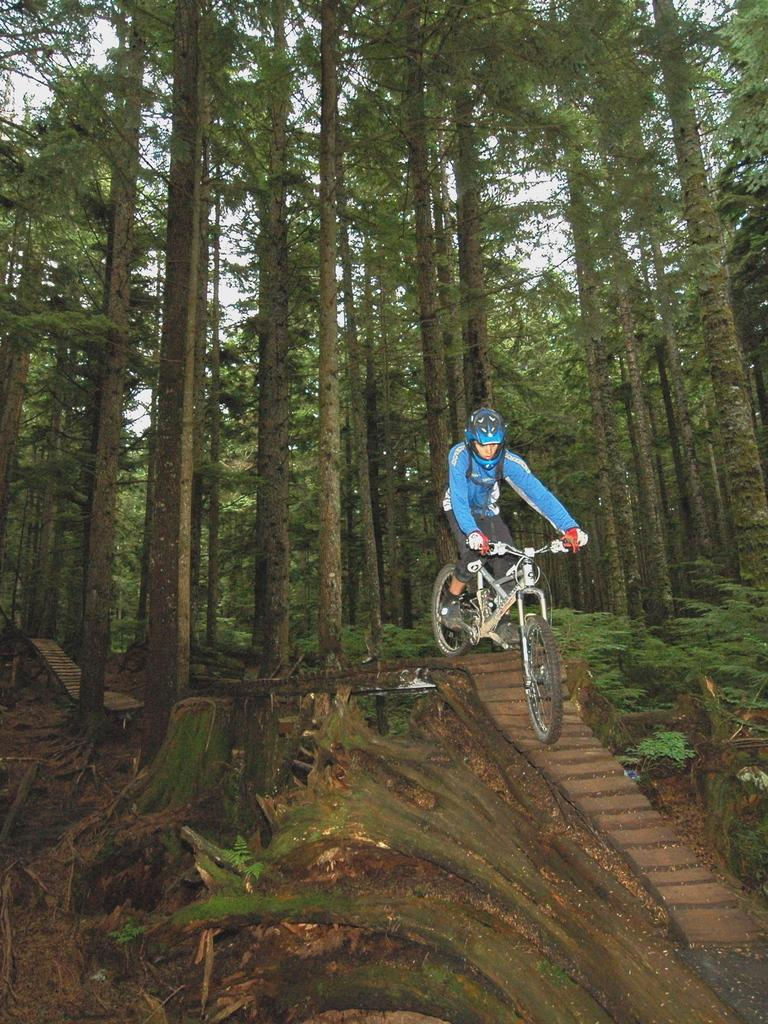What is the main subject of the image? There is a person in the image. What is the person doing in the image? The person is riding a bicycle. What can be seen in the background of the image? There are trees visible in the background of the image. What color is the ball that the person is holding in the image? There is no ball present in the image; the person is riding a bicycle. 